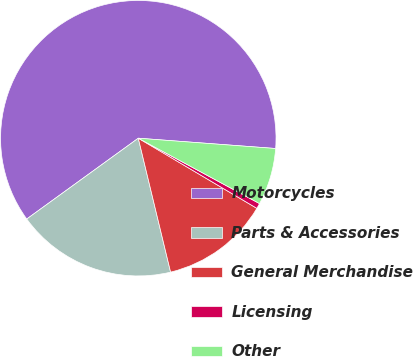Convert chart. <chart><loc_0><loc_0><loc_500><loc_500><pie_chart><fcel>Motorcycles<fcel>Parts & Accessories<fcel>General Merchandise<fcel>Licensing<fcel>Other<nl><fcel>61.17%<fcel>18.79%<fcel>12.73%<fcel>0.63%<fcel>6.68%<nl></chart> 